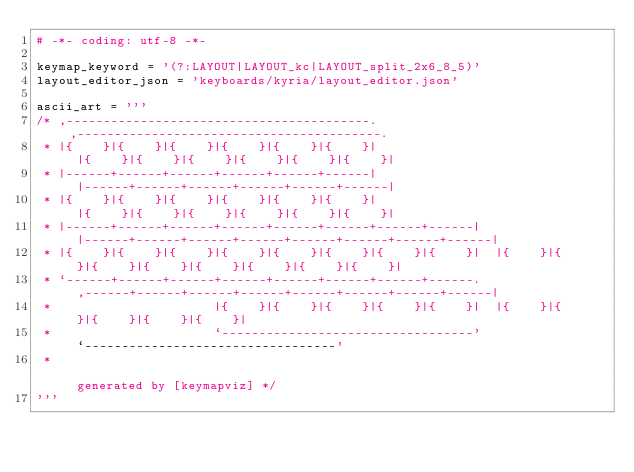<code> <loc_0><loc_0><loc_500><loc_500><_Python_># -*- coding: utf-8 -*-

keymap_keyword = '(?:LAYOUT|LAYOUT_kc|LAYOUT_split_2x6_8_5)'
layout_editor_json = 'keyboards/kyria/layout_editor.json'

ascii_art = '''
/* ,-----------------------------------------.                              ,-----------------------------------------.
 * |{    }|{    }|{    }|{    }|{    }|{    }|                              |{    }|{    }|{    }|{    }|{    }|{    }|
 * |------+------+------+------+------+------|                              |------+------+------+------+------+------|
 * |{    }|{    }|{    }|{    }|{    }|{    }|                              |{    }|{    }|{    }|{    }|{    }|{    }|
 * |------+------+------+------+------+------+------+------|  |------+------+------+------+------+------+------+------|
 * |{    }|{    }|{    }|{    }|{    }|{    }|{    }|{    }|  |{    }|{    }|{    }|{    }|{    }|{    }|{    }|{    }|
 * `------+------+------+------+------+------+------+------.  ,------+------+------+------+------+------+------+------|
 *                      |{    }|{    }|{    }|{    }|{    }|  |{    }|{    }|{    }|{    }|{    }|
 *                      `----------------------------------'  `----------------------------------'
 *                                                                               generated by [keymapviz] */
'''

</code> 